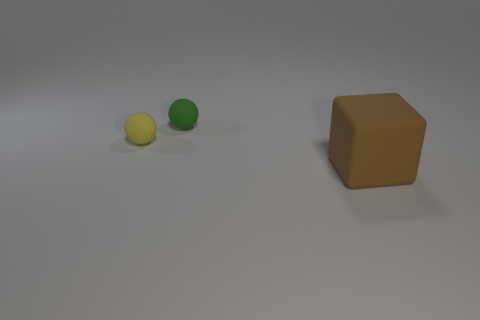Add 2 tiny blue rubber blocks. How many objects exist? 5 Subtract all green spheres. How many spheres are left? 1 Subtract all blocks. How many objects are left? 2 Subtract 1 cubes. How many cubes are left? 0 Subtract all red balls. Subtract all purple blocks. How many balls are left? 2 Add 3 blocks. How many blocks exist? 4 Subtract 1 brown cubes. How many objects are left? 2 Subtract all yellow spheres. How many blue cubes are left? 0 Subtract all large blocks. Subtract all big rubber cylinders. How many objects are left? 2 Add 2 tiny yellow rubber things. How many tiny yellow rubber things are left? 3 